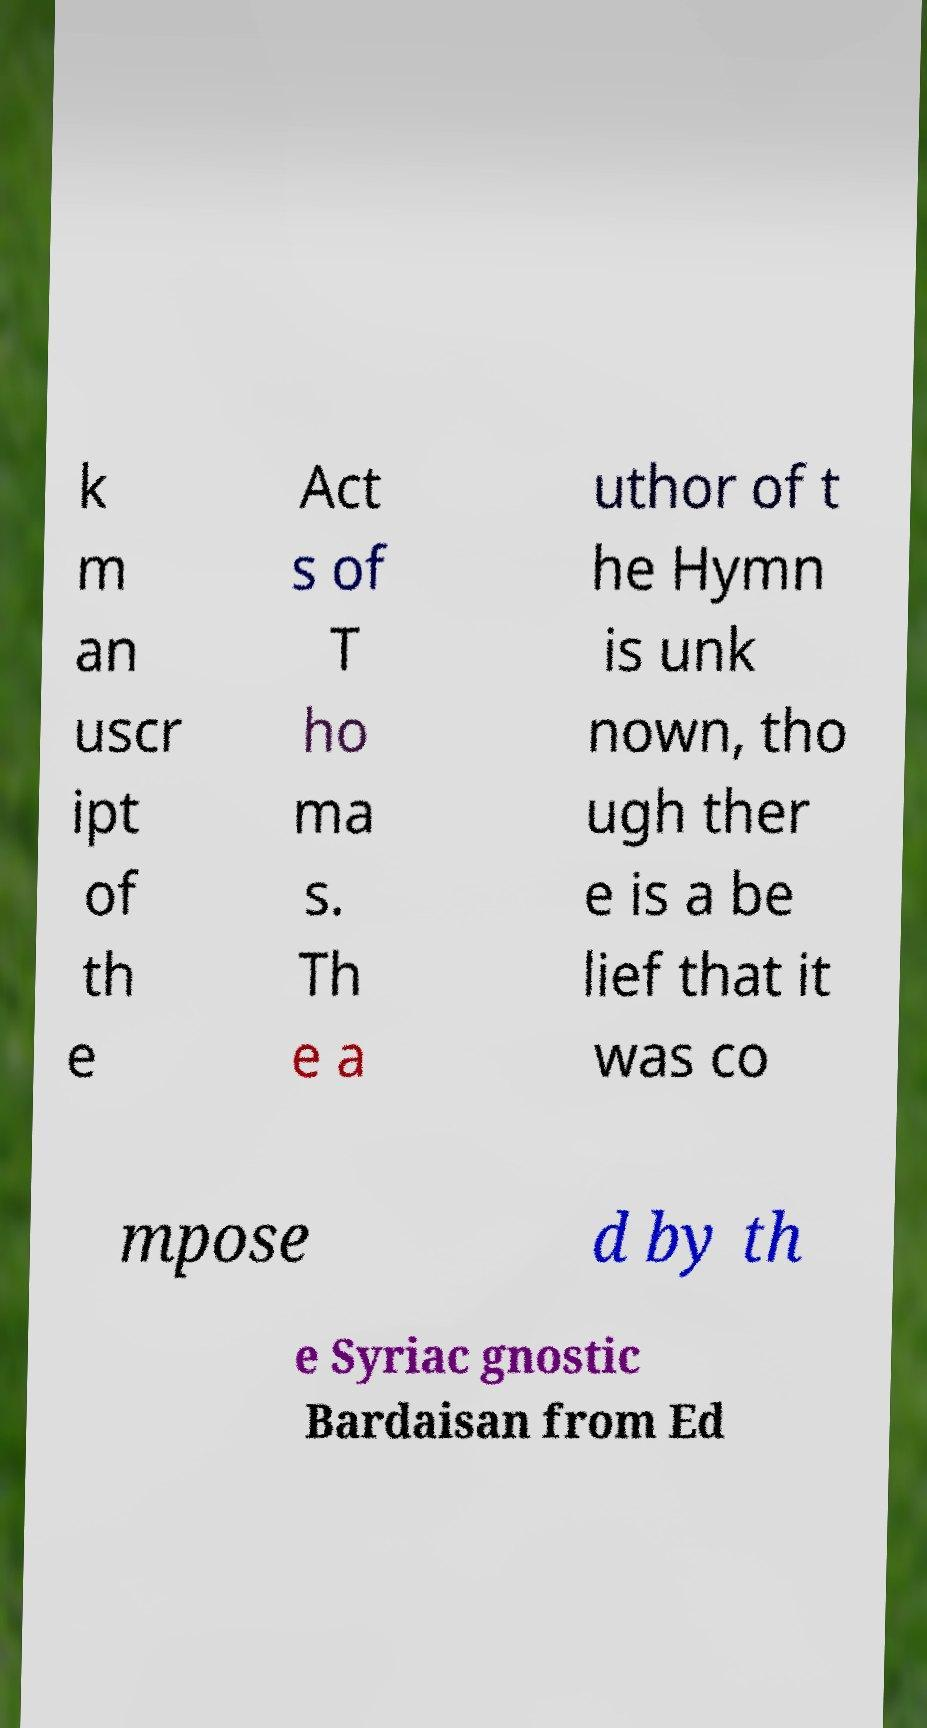There's text embedded in this image that I need extracted. Can you transcribe it verbatim? k m an uscr ipt of th e Act s of T ho ma s. Th e a uthor of t he Hymn is unk nown, tho ugh ther e is a be lief that it was co mpose d by th e Syriac gnostic Bardaisan from Ed 